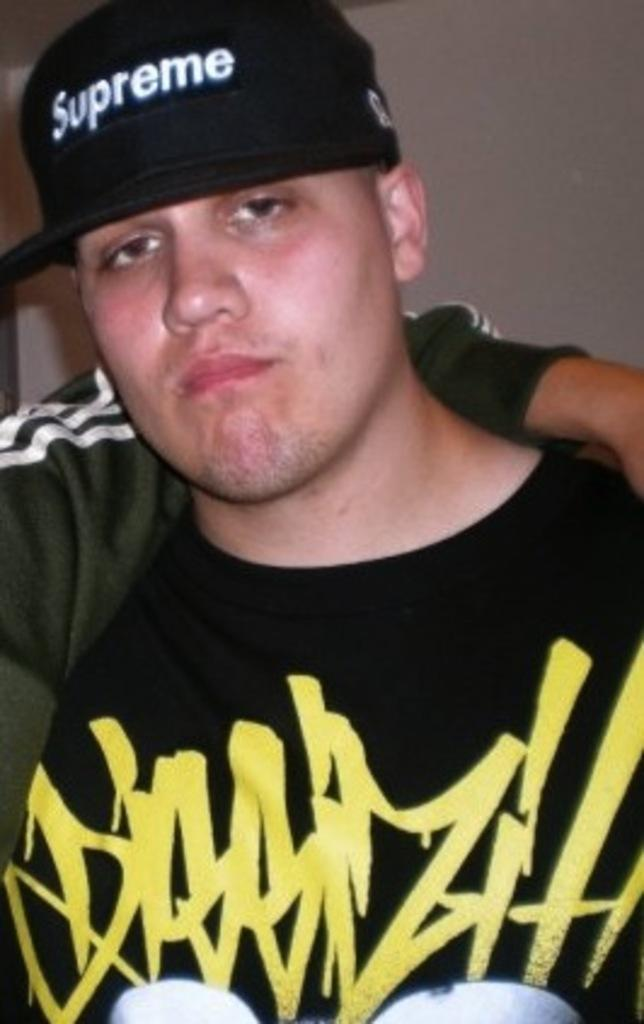Provide a one-sentence caption for the provided image. a white male wearing a black shirt with a black hat that says supreme. 